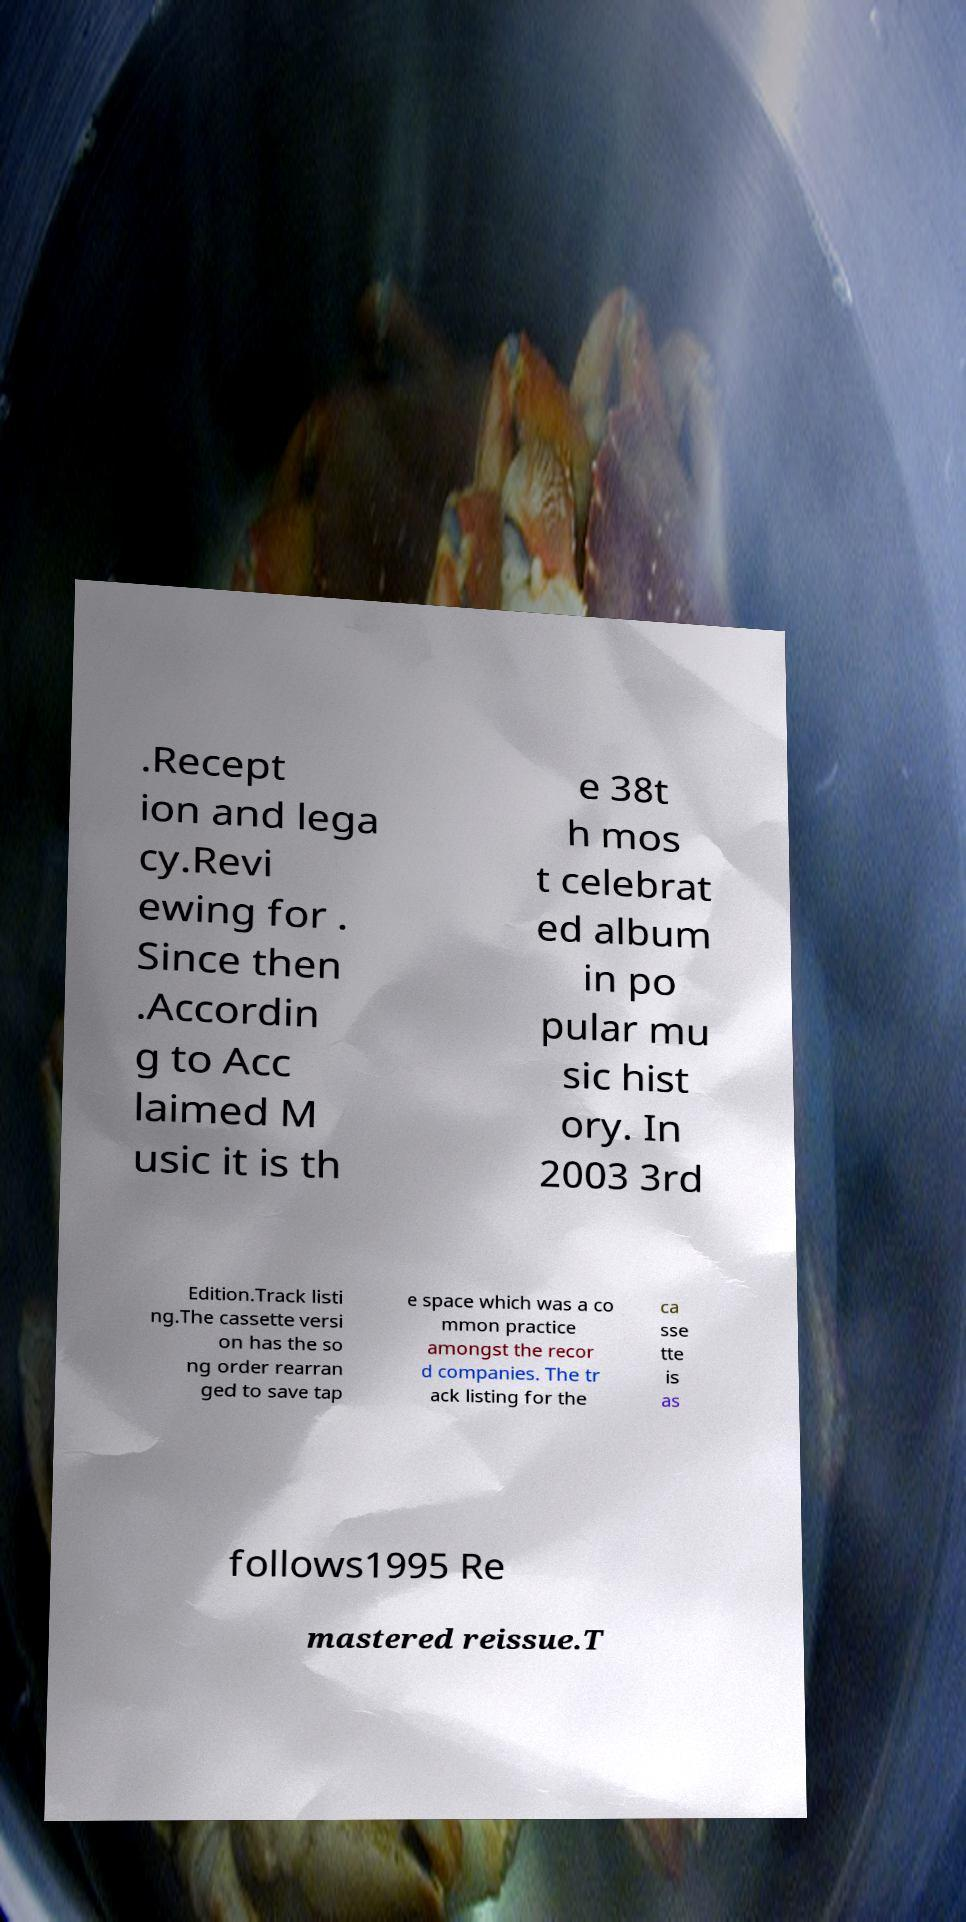Could you extract and type out the text from this image? .Recept ion and lega cy.Revi ewing for . Since then .Accordin g to Acc laimed M usic it is th e 38t h mos t celebrat ed album in po pular mu sic hist ory. In 2003 3rd Edition.Track listi ng.The cassette versi on has the so ng order rearran ged to save tap e space which was a co mmon practice amongst the recor d companies. The tr ack listing for the ca sse tte is as follows1995 Re mastered reissue.T 